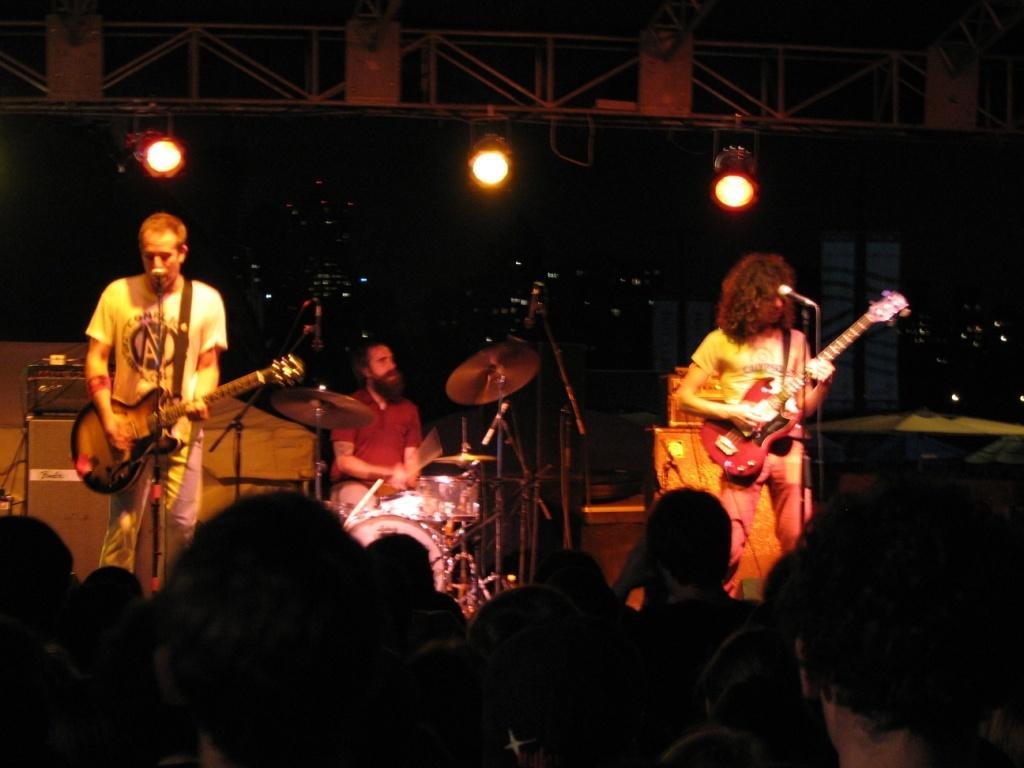Could you give a brief overview of what you see in this image? There are three members on the stage. Two of them were playing guitars in their hands in front of a mic. Another guy is sitting in the background and playing drums. There are some people watching them in the down. In the background there are some lights. 